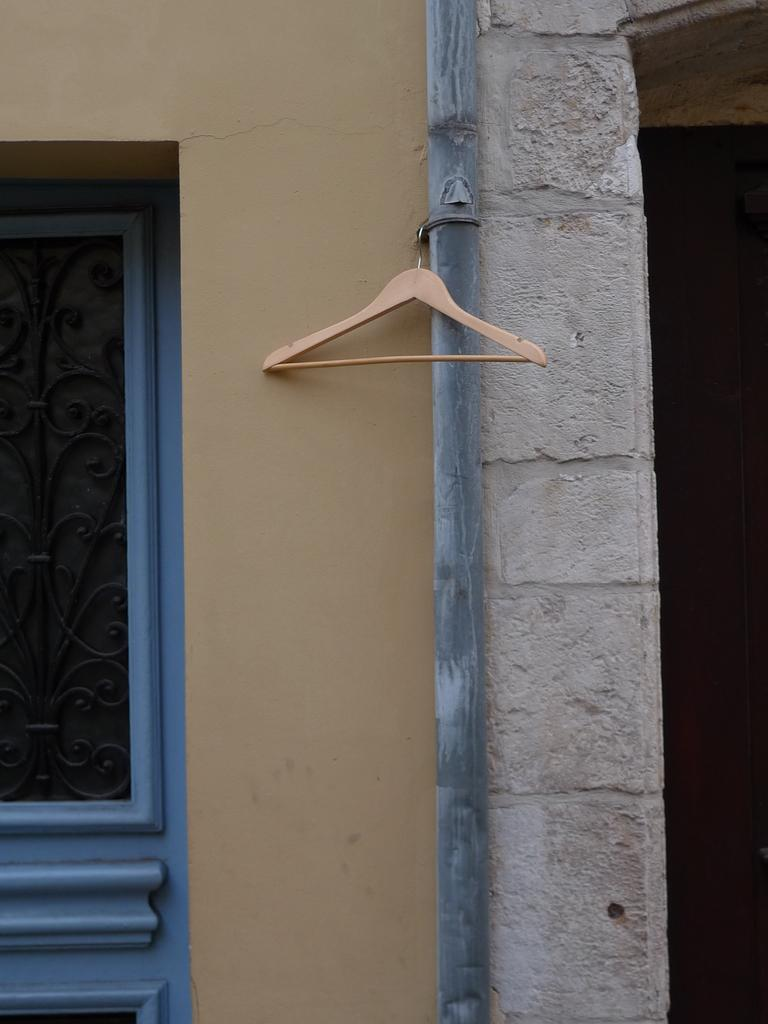What is attached to the pole in the image? There is a hanger attached to a pole in the image. What can be seen behind the pole in the image? There is a wall visible in the image. What architectural feature is present in the wall? There is a window in the image. How many beds can be seen in the image? There are no beds present in the image. 